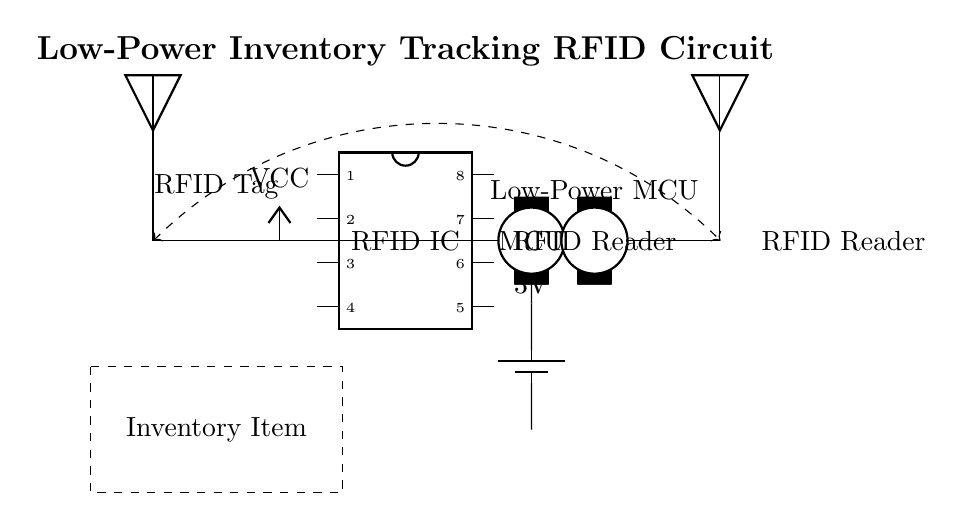What is the main power source for this circuit? The main power source is a battery, specifically a 3V battery illustrated in the circuit diagram. This is indicated by the battery symbol and the label next to it.
Answer: 3V battery What connects the RFID IC to the microcontroller? The RFID IC is directly connected to the microcontroller with a wire connection, indicated by the line connecting them in the diagram. This shows that they communicate with each other.
Answer: A wire What type of antenna is used in this circuit? The circuit diagram includes an antenna representing the RFID tag, which suggests that it operates as an RFID transponder.
Answer: RFID antenna How does the RFID tag communicate with the RFID reader? The RFID tag communicates wirelessly with the RFID reader, as shown by the dashed arrow labeled as a wireless connection between the tag and the reader. This signifies the indirect communication through radio waves.
Answer: Wirelessly What is the function of the microcontroller in this circuit? The microcontroller (MCU) controls the operations of the RFID circuit by processing the signals from the RFID IC and managing communications to the RFID reader. This is inferred from its central position in the diagram connecting different components.
Answer: Control operations 